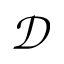Convert formula to latex. <formula><loc_0><loc_0><loc_500><loc_500>\mathcal { D }</formula> 